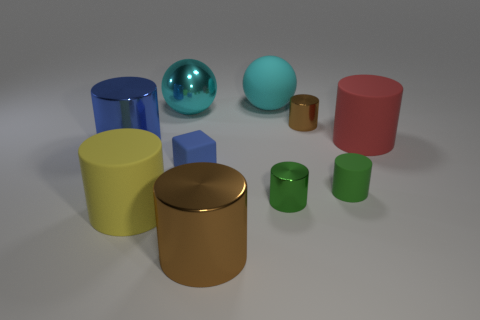Subtract 2 cylinders. How many cylinders are left? 5 Subtract all yellow cylinders. How many cylinders are left? 6 Subtract all yellow cylinders. How many cylinders are left? 6 Subtract all yellow cylinders. Subtract all gray cubes. How many cylinders are left? 6 Subtract all cylinders. How many objects are left? 3 Subtract 0 gray cylinders. How many objects are left? 10 Subtract all small cubes. Subtract all small metallic cylinders. How many objects are left? 7 Add 1 green objects. How many green objects are left? 3 Add 5 large cylinders. How many large cylinders exist? 9 